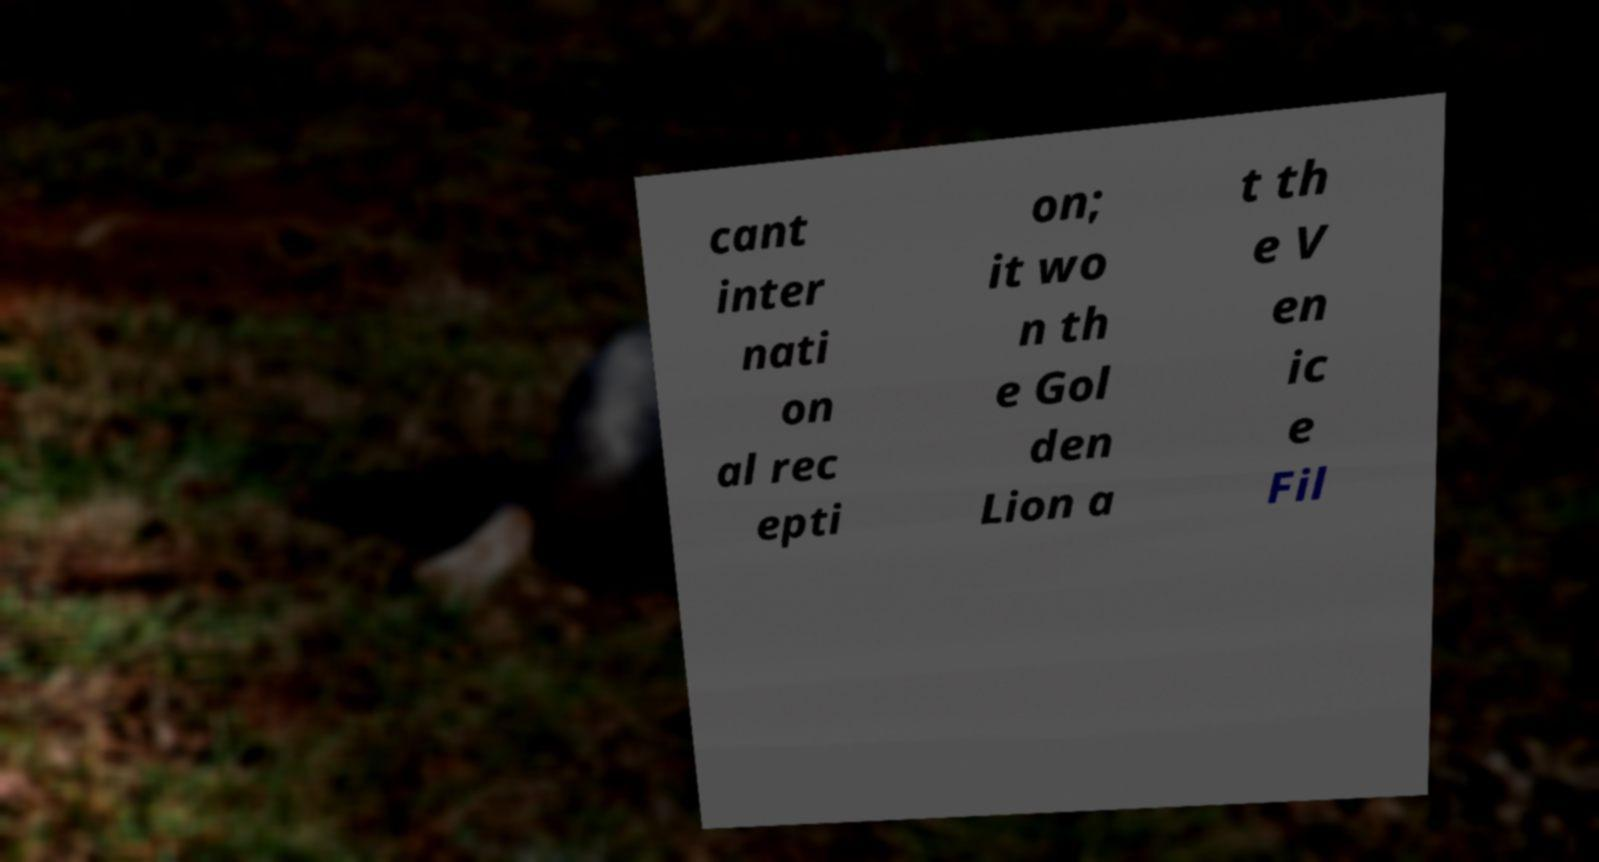Please read and relay the text visible in this image. What does it say? cant inter nati on al rec epti on; it wo n th e Gol den Lion a t th e V en ic e Fil 